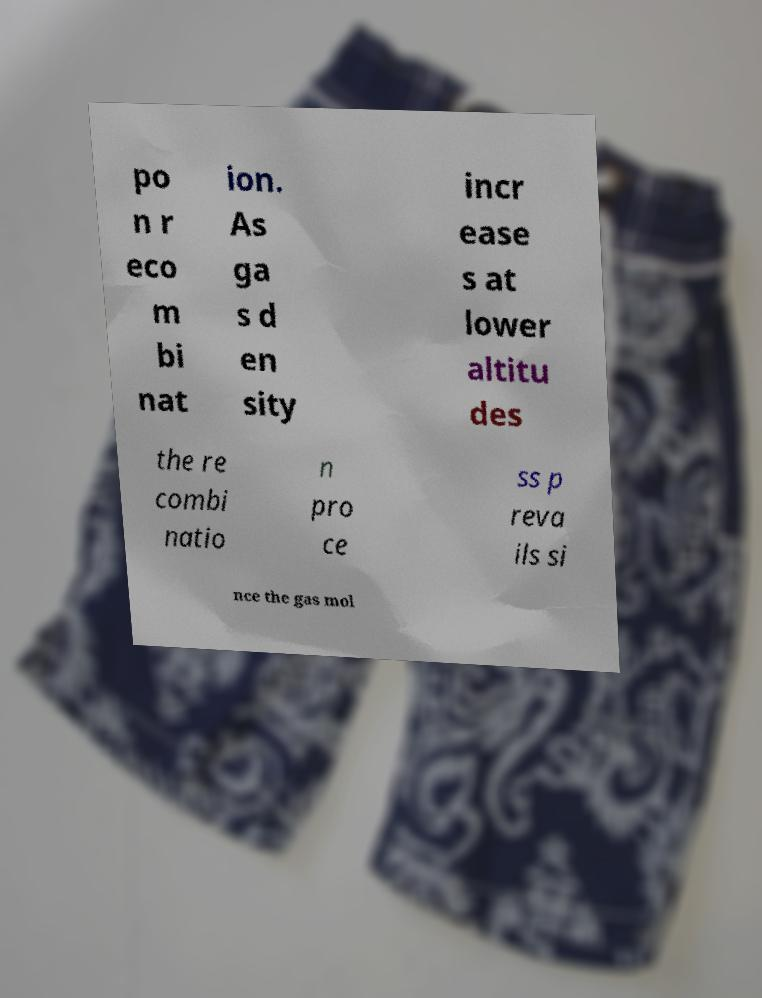I need the written content from this picture converted into text. Can you do that? po n r eco m bi nat ion. As ga s d en sity incr ease s at lower altitu des the re combi natio n pro ce ss p reva ils si nce the gas mol 